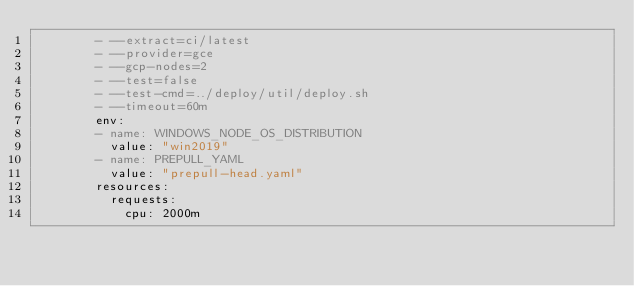<code> <loc_0><loc_0><loc_500><loc_500><_YAML_>        - --extract=ci/latest
        - --provider=gce
        - --gcp-nodes=2
        - --test=false
        - --test-cmd=../deploy/util/deploy.sh
        - --timeout=60m
        env:
        - name: WINDOWS_NODE_OS_DISTRIBUTION
          value: "win2019"
        - name: PREPULL_YAML
          value: "prepull-head.yaml"
        resources:
          requests:
            cpu: 2000m
</code> 